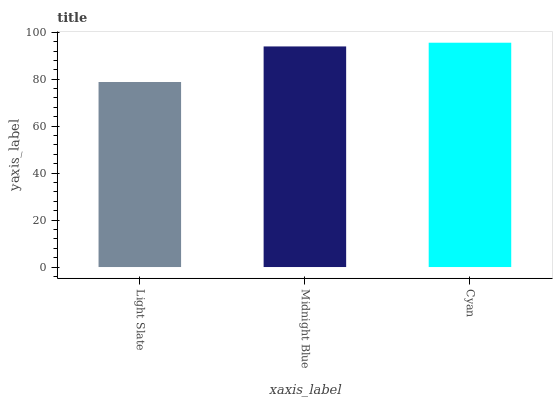Is Light Slate the minimum?
Answer yes or no. Yes. Is Cyan the maximum?
Answer yes or no. Yes. Is Midnight Blue the minimum?
Answer yes or no. No. Is Midnight Blue the maximum?
Answer yes or no. No. Is Midnight Blue greater than Light Slate?
Answer yes or no. Yes. Is Light Slate less than Midnight Blue?
Answer yes or no. Yes. Is Light Slate greater than Midnight Blue?
Answer yes or no. No. Is Midnight Blue less than Light Slate?
Answer yes or no. No. Is Midnight Blue the high median?
Answer yes or no. Yes. Is Midnight Blue the low median?
Answer yes or no. Yes. Is Light Slate the high median?
Answer yes or no. No. Is Cyan the low median?
Answer yes or no. No. 